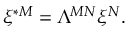Convert formula to latex. <formula><loc_0><loc_0><loc_500><loc_500>\xi ^ { * M } = \Lambda ^ { M N } \xi ^ { N } .</formula> 